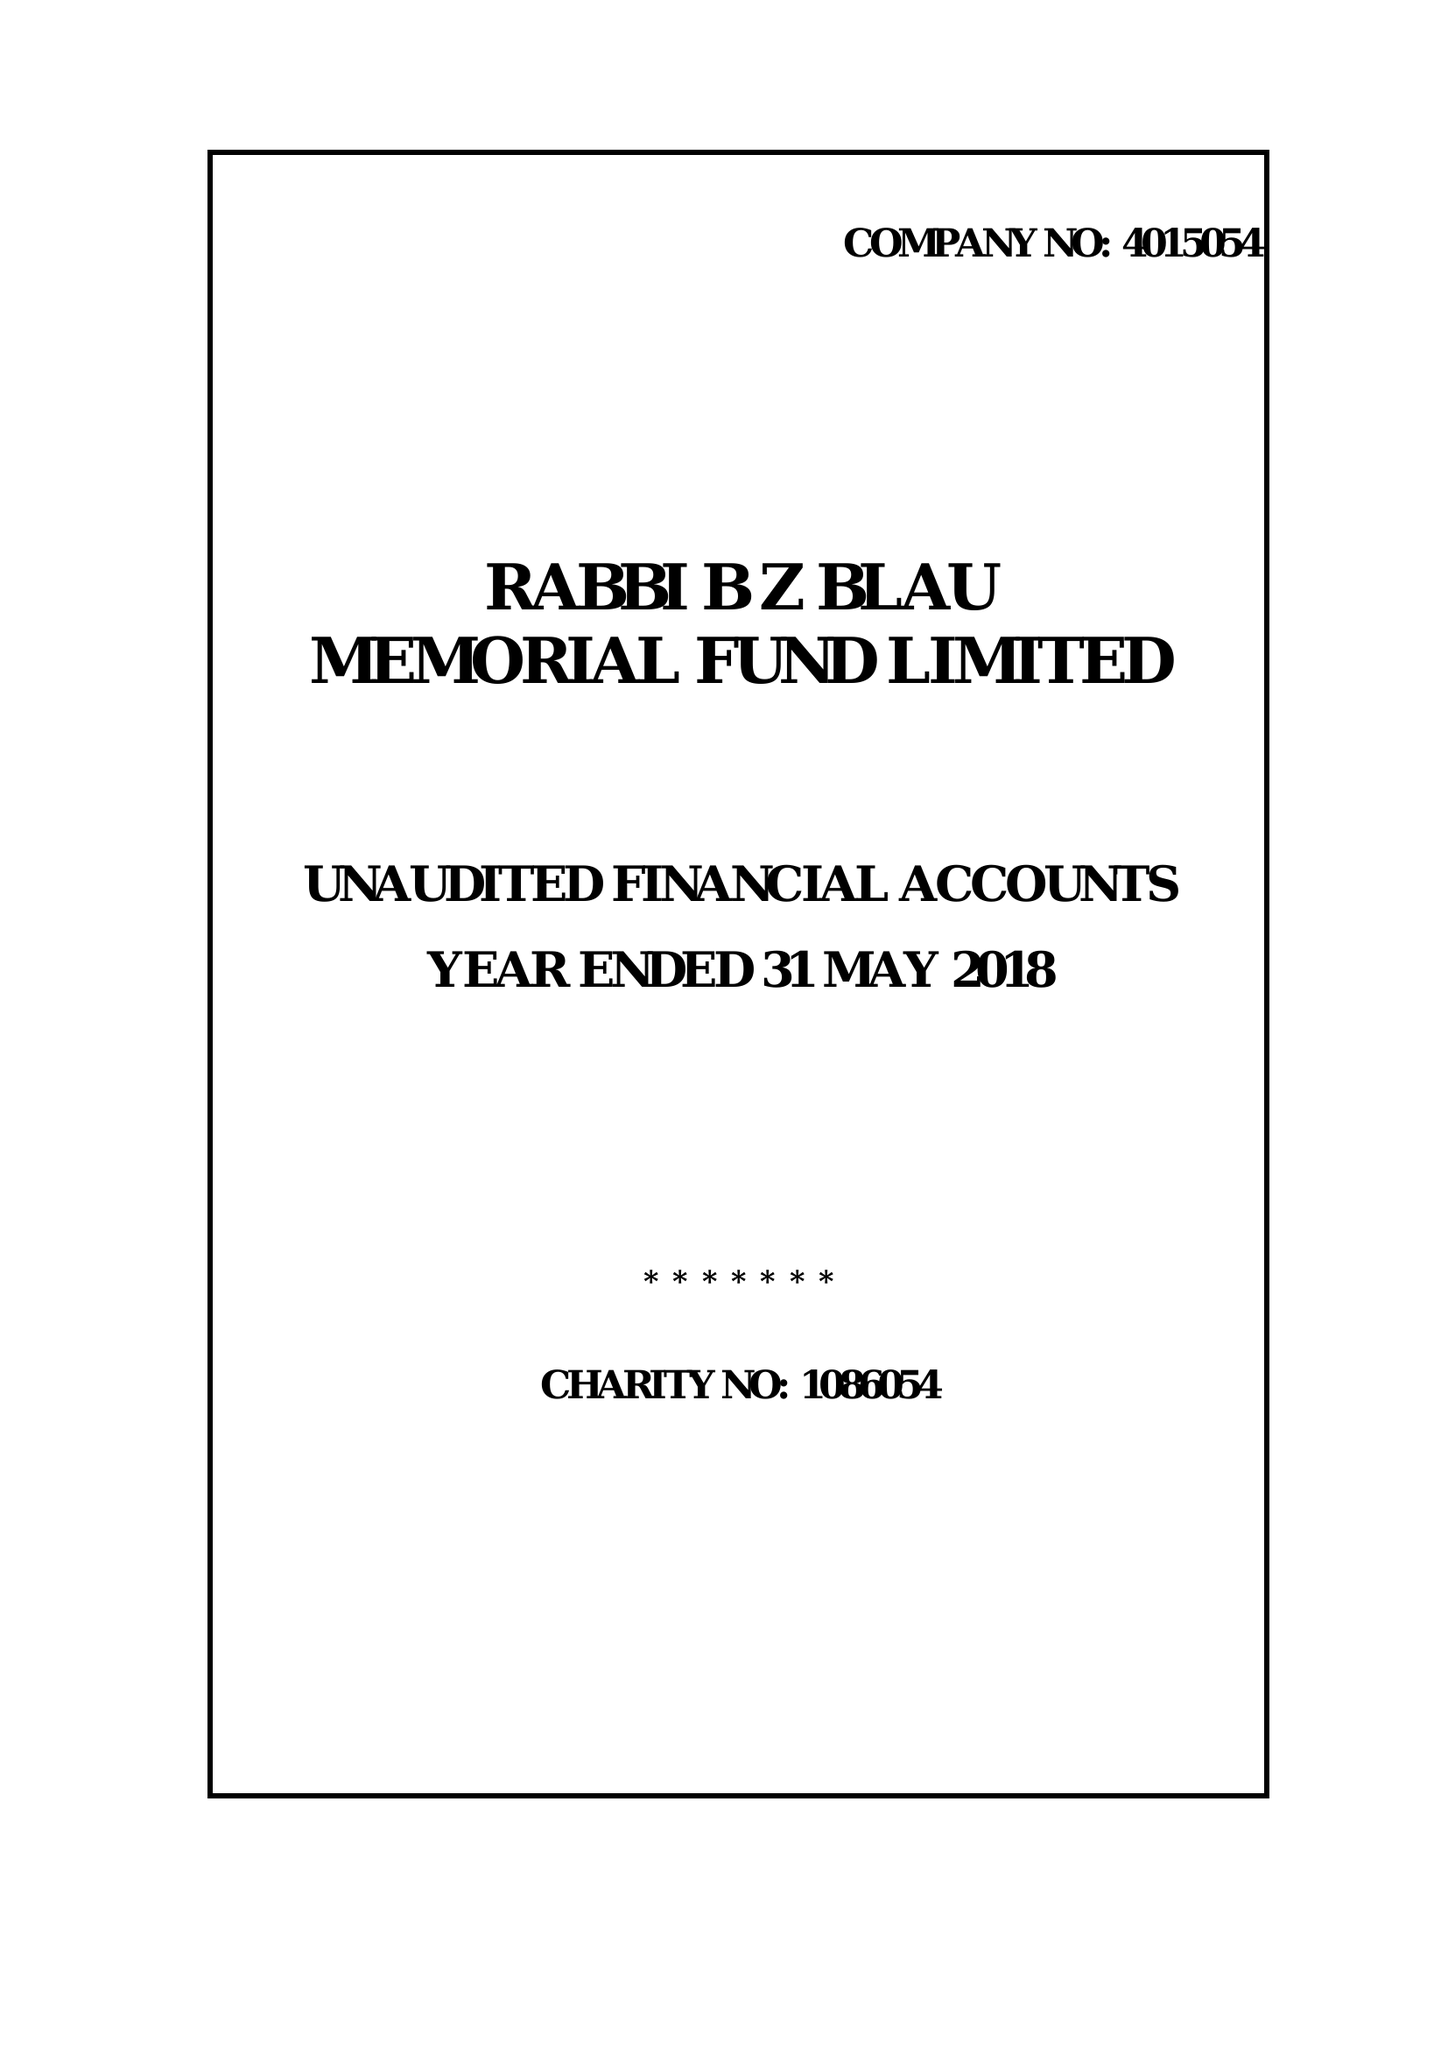What is the value for the charity_name?
Answer the question using a single word or phrase. Rabbi B Z Blau Memorial Fund Ltd. 